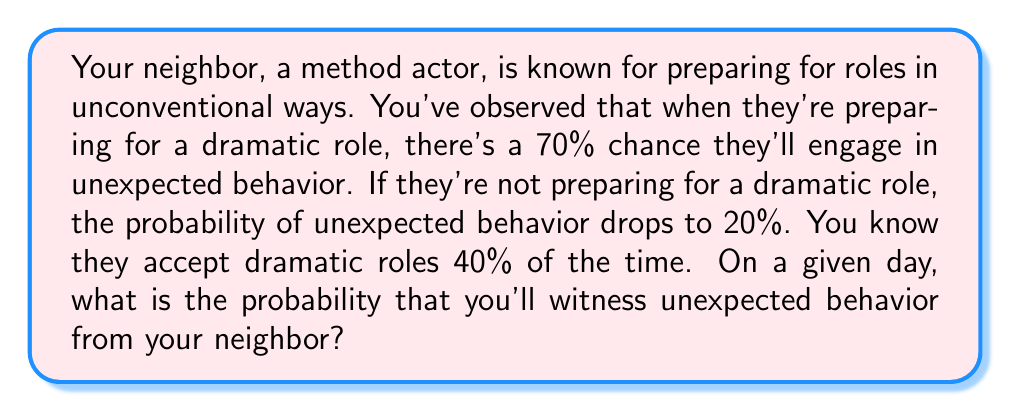Can you solve this math problem? Let's approach this problem using conditional probability and the law of total probability.

Define the events:
$D$: The actor is preparing for a dramatic role
$U$: The actor exhibits unexpected behavior

Given:
$P(U|D) = 0.70$ (probability of unexpected behavior given a dramatic role)
$P(U|\text{not }D) = 0.20$ (probability of unexpected behavior given not a dramatic role)
$P(D) = 0.40$ (probability of preparing for a dramatic role)

We can calculate $P(\text{not }D) = 1 - P(D) = 0.60$

Using the law of total probability:

$$P(U) = P(U|D) \cdot P(D) + P(U|\text{not }D) \cdot P(\text{not }D)$$

Substituting the values:

$$\begin{align*}
P(U) &= 0.70 \cdot 0.40 + 0.20 \cdot 0.60 \\
&= 0.28 + 0.12 \\
&= 0.40
\end{align*}$$

Therefore, the probability of witnessing unexpected behavior on a given day is 0.40 or 40%.
Answer: $0.40$ or $40\%$ 